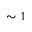Convert formula to latex. <formula><loc_0><loc_0><loc_500><loc_500>\sim 1</formula> 